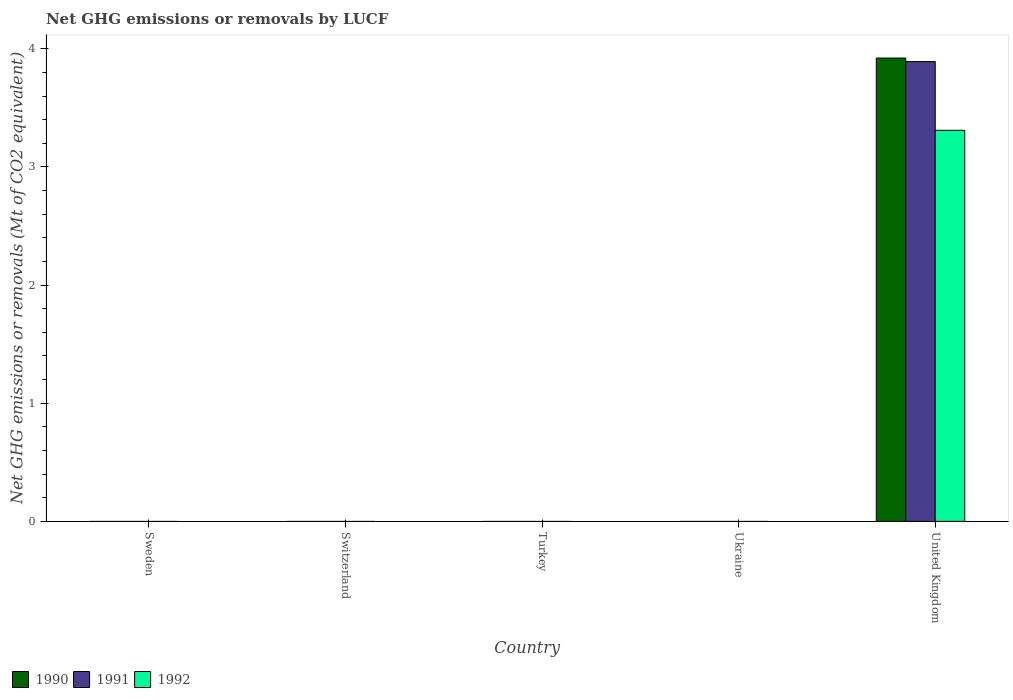Are the number of bars per tick equal to the number of legend labels?
Your answer should be very brief. No. What is the label of the 1st group of bars from the left?
Offer a terse response. Sweden. What is the net GHG emissions or removals by LUCF in 1990 in United Kingdom?
Provide a short and direct response. 3.92. Across all countries, what is the maximum net GHG emissions or removals by LUCF in 1990?
Offer a terse response. 3.92. Across all countries, what is the minimum net GHG emissions or removals by LUCF in 1992?
Offer a terse response. 0. In which country was the net GHG emissions or removals by LUCF in 1991 maximum?
Provide a short and direct response. United Kingdom. What is the total net GHG emissions or removals by LUCF in 1990 in the graph?
Ensure brevity in your answer.  3.92. What is the difference between the net GHG emissions or removals by LUCF in 1990 in Switzerland and the net GHG emissions or removals by LUCF in 1991 in Turkey?
Keep it short and to the point. 0. What is the average net GHG emissions or removals by LUCF in 1990 per country?
Your answer should be very brief. 0.78. What is the difference between the net GHG emissions or removals by LUCF of/in 1991 and net GHG emissions or removals by LUCF of/in 1990 in United Kingdom?
Give a very brief answer. -0.03. What is the difference between the highest and the lowest net GHG emissions or removals by LUCF in 1992?
Ensure brevity in your answer.  3.31. Is it the case that in every country, the sum of the net GHG emissions or removals by LUCF in 1990 and net GHG emissions or removals by LUCF in 1991 is greater than the net GHG emissions or removals by LUCF in 1992?
Your answer should be very brief. No. Are all the bars in the graph horizontal?
Provide a short and direct response. No. How many countries are there in the graph?
Make the answer very short. 5. Does the graph contain any zero values?
Your response must be concise. Yes. What is the title of the graph?
Your answer should be compact. Net GHG emissions or removals by LUCF. What is the label or title of the Y-axis?
Give a very brief answer. Net GHG emissions or removals (Mt of CO2 equivalent). What is the Net GHG emissions or removals (Mt of CO2 equivalent) in 1990 in Sweden?
Keep it short and to the point. 0. What is the Net GHG emissions or removals (Mt of CO2 equivalent) of 1991 in Sweden?
Offer a terse response. 0. What is the Net GHG emissions or removals (Mt of CO2 equivalent) of 1992 in Sweden?
Give a very brief answer. 0. What is the Net GHG emissions or removals (Mt of CO2 equivalent) of 1992 in Switzerland?
Provide a succinct answer. 0. What is the Net GHG emissions or removals (Mt of CO2 equivalent) in 1990 in Turkey?
Make the answer very short. 0. What is the Net GHG emissions or removals (Mt of CO2 equivalent) of 1991 in Ukraine?
Offer a terse response. 0. What is the Net GHG emissions or removals (Mt of CO2 equivalent) of 1990 in United Kingdom?
Ensure brevity in your answer.  3.92. What is the Net GHG emissions or removals (Mt of CO2 equivalent) in 1991 in United Kingdom?
Give a very brief answer. 3.89. What is the Net GHG emissions or removals (Mt of CO2 equivalent) of 1992 in United Kingdom?
Offer a terse response. 3.31. Across all countries, what is the maximum Net GHG emissions or removals (Mt of CO2 equivalent) in 1990?
Make the answer very short. 3.92. Across all countries, what is the maximum Net GHG emissions or removals (Mt of CO2 equivalent) in 1991?
Make the answer very short. 3.89. Across all countries, what is the maximum Net GHG emissions or removals (Mt of CO2 equivalent) of 1992?
Ensure brevity in your answer.  3.31. Across all countries, what is the minimum Net GHG emissions or removals (Mt of CO2 equivalent) in 1990?
Give a very brief answer. 0. Across all countries, what is the minimum Net GHG emissions or removals (Mt of CO2 equivalent) in 1992?
Your response must be concise. 0. What is the total Net GHG emissions or removals (Mt of CO2 equivalent) of 1990 in the graph?
Ensure brevity in your answer.  3.92. What is the total Net GHG emissions or removals (Mt of CO2 equivalent) of 1991 in the graph?
Give a very brief answer. 3.89. What is the total Net GHG emissions or removals (Mt of CO2 equivalent) of 1992 in the graph?
Provide a short and direct response. 3.31. What is the average Net GHG emissions or removals (Mt of CO2 equivalent) in 1990 per country?
Give a very brief answer. 0.78. What is the average Net GHG emissions or removals (Mt of CO2 equivalent) in 1991 per country?
Provide a succinct answer. 0.78. What is the average Net GHG emissions or removals (Mt of CO2 equivalent) in 1992 per country?
Keep it short and to the point. 0.66. What is the difference between the Net GHG emissions or removals (Mt of CO2 equivalent) in 1990 and Net GHG emissions or removals (Mt of CO2 equivalent) in 1991 in United Kingdom?
Make the answer very short. 0.03. What is the difference between the Net GHG emissions or removals (Mt of CO2 equivalent) in 1990 and Net GHG emissions or removals (Mt of CO2 equivalent) in 1992 in United Kingdom?
Your answer should be compact. 0.61. What is the difference between the Net GHG emissions or removals (Mt of CO2 equivalent) in 1991 and Net GHG emissions or removals (Mt of CO2 equivalent) in 1992 in United Kingdom?
Give a very brief answer. 0.58. What is the difference between the highest and the lowest Net GHG emissions or removals (Mt of CO2 equivalent) of 1990?
Your answer should be compact. 3.92. What is the difference between the highest and the lowest Net GHG emissions or removals (Mt of CO2 equivalent) in 1991?
Keep it short and to the point. 3.89. What is the difference between the highest and the lowest Net GHG emissions or removals (Mt of CO2 equivalent) in 1992?
Your answer should be very brief. 3.31. 